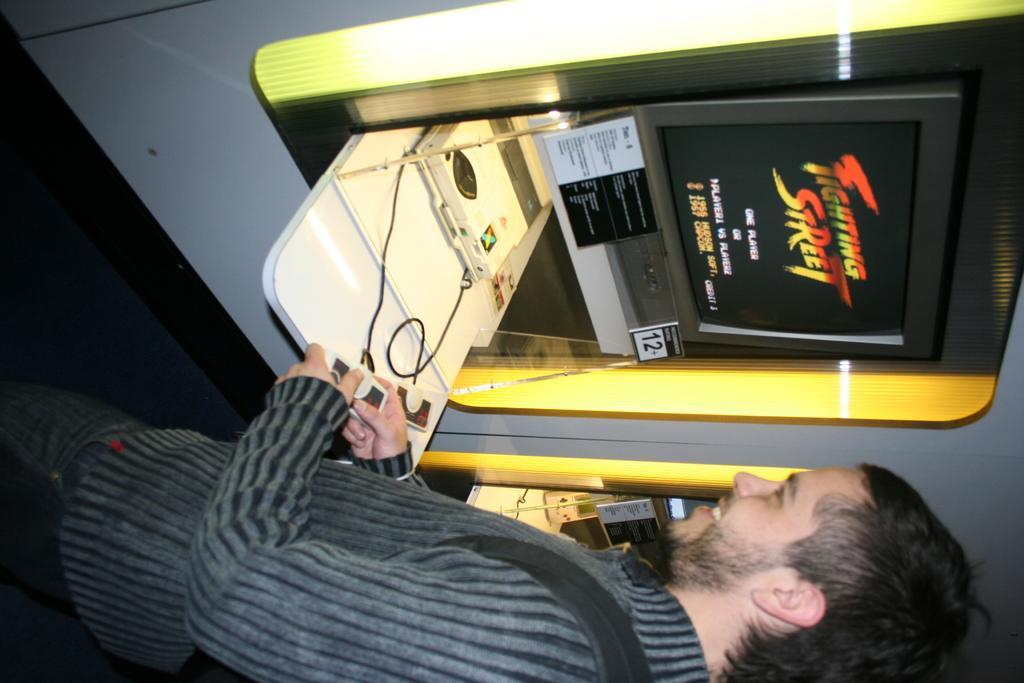In one or two sentences, can you explain what this image depicts? In this image I can see a person standing and holding some object. There is a screen attached to some object, there are boards and there are some other objects. 